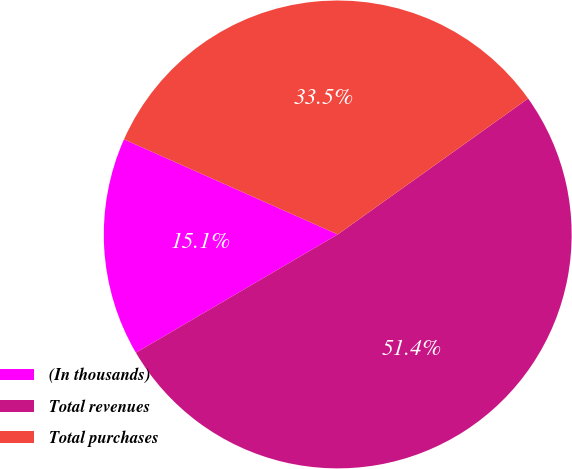<chart> <loc_0><loc_0><loc_500><loc_500><pie_chart><fcel>(In thousands)<fcel>Total revenues<fcel>Total purchases<nl><fcel>15.1%<fcel>51.43%<fcel>33.47%<nl></chart> 